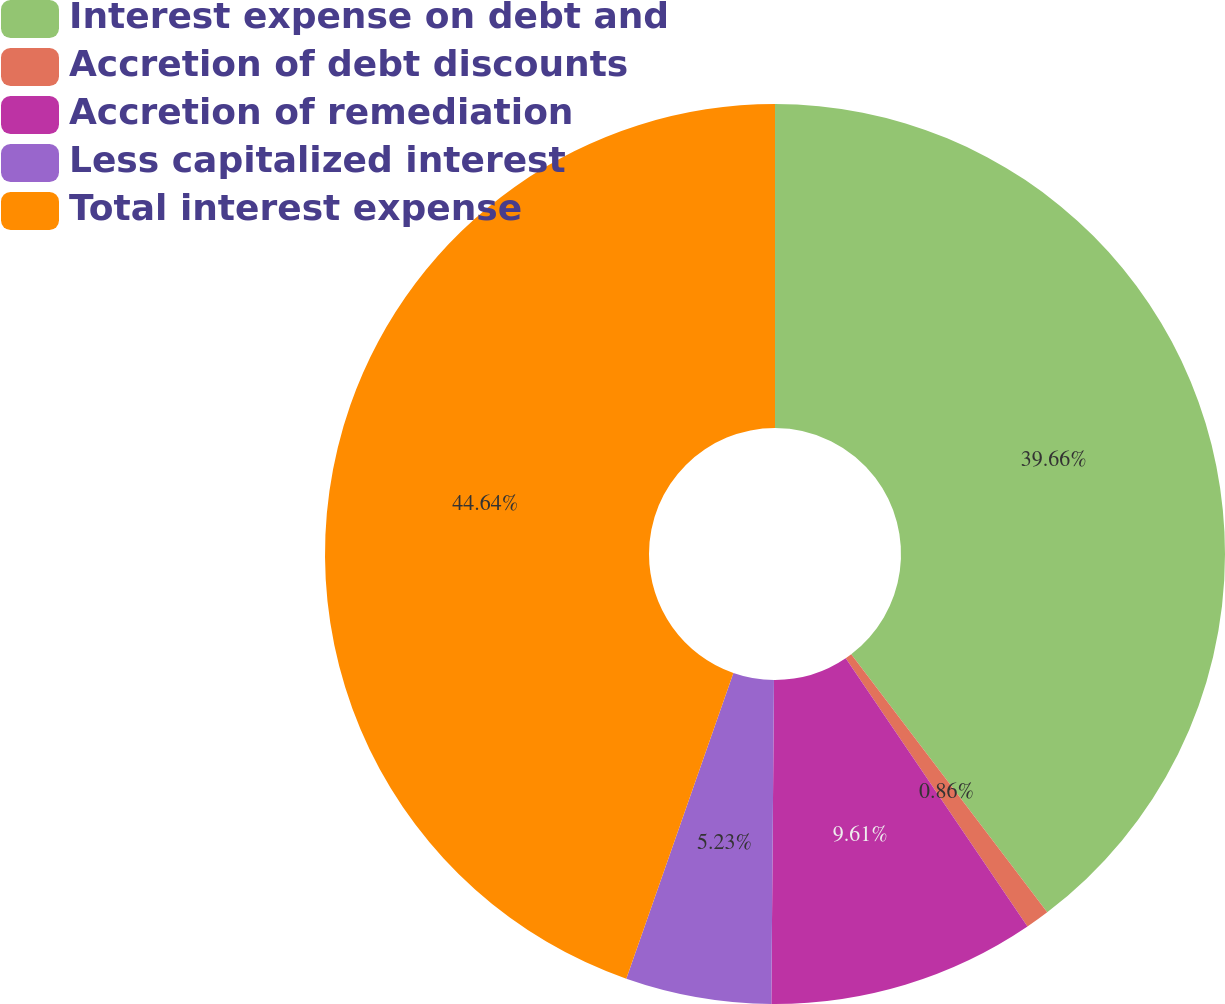Convert chart to OTSL. <chart><loc_0><loc_0><loc_500><loc_500><pie_chart><fcel>Interest expense on debt and<fcel>Accretion of debt discounts<fcel>Accretion of remediation<fcel>Less capitalized interest<fcel>Total interest expense<nl><fcel>39.66%<fcel>0.86%<fcel>9.61%<fcel>5.23%<fcel>44.64%<nl></chart> 